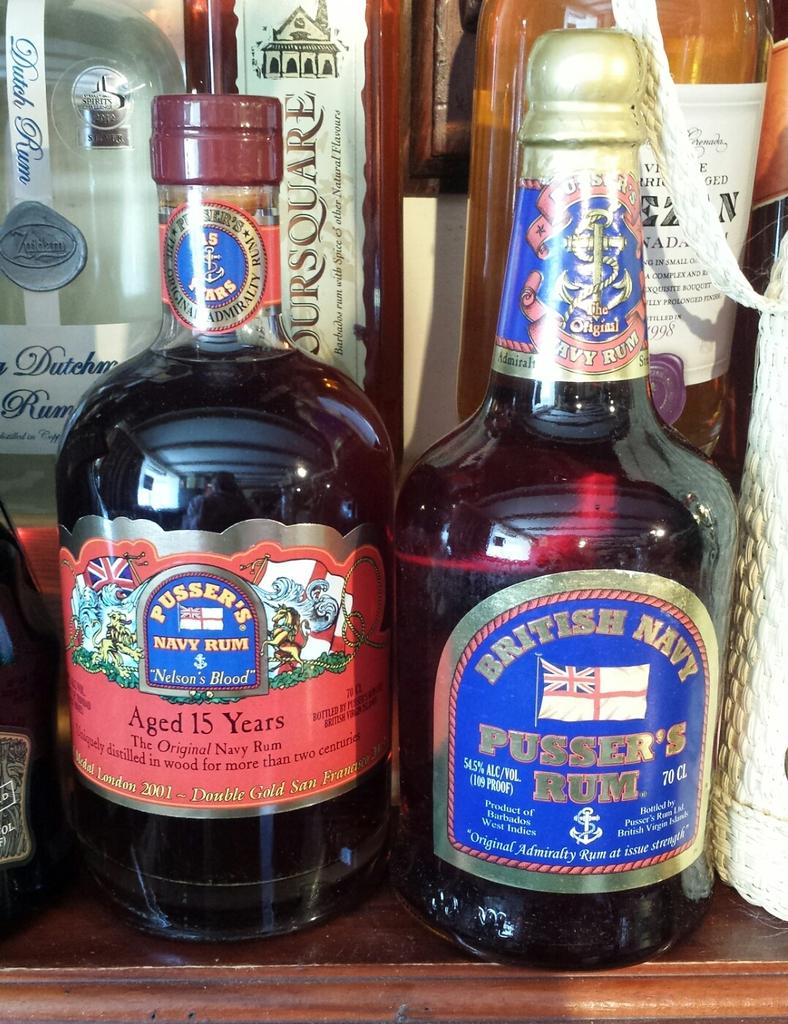How many years had the red bottle liquor been aged?
Keep it short and to the point. 15. Which country name is printed in the pusser's rum?
Ensure brevity in your answer.  Britain. 